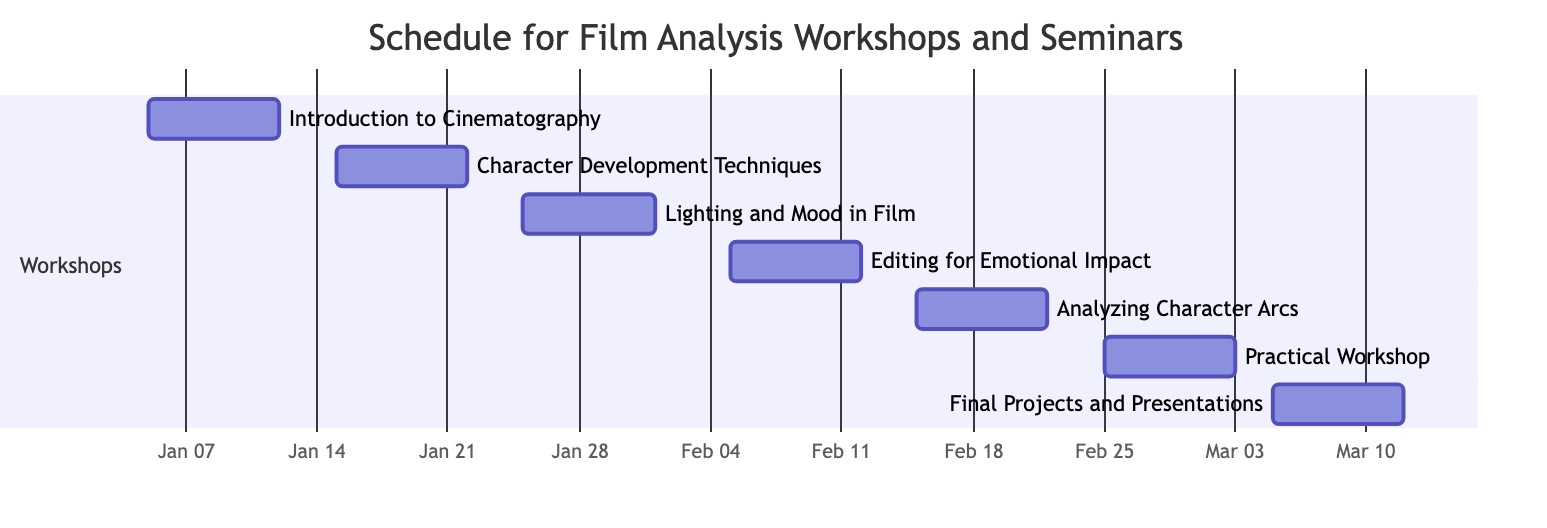What is the duration of the "Editing for Emotional Impact" workshop? The duration of a workshop in a Gantt chart can be found next to its title. For "Editing for Emotional Impact", the duration is indicated as 7 days.
Answer: 7 days Which workshop occurs right after "Lighting and Mood in Film"? To determine which workshop occurs next, we can look at the end date of "Lighting and Mood in Film", which is February 1, 2024. The next workshop starts on February 5, 2024, which is "Editing for Emotional Impact".
Answer: Editing for Emotional Impact How many workshops are scheduled between January 15, 2024, and February 15, 2024? We check the workshops starting between the given dates. "Character Development Techniques" starts on January 15 and "Lighting and Mood in Film" begins on January 25, followed by "Editing for Emotional Impact" starting on February 5 and "Analyzing Character Arcs" on February 15. There are four workshops in this timeframe.
Answer: 4 What is the title of the last workshop scheduled in the diagram? The last workshop can be identified by looking at the section where the workshops are listed and identifying the one that is positioned furthest on the timeline. The final workshop is "Final Projects and Presentations".
Answer: Final Projects and Presentations Is there any overlap between "Practical Workshop: Shooting Scenes" and "Final Projects and Presentations"? We check the start and end dates of both workshops. "Practical Workshop: Shooting Scenes" runs from February 25 to March 3, 2024, and "Final Projects and Presentations" starts on March 5, 2024. Since there is no overlap in the date ranges, the answer is no.
Answer: No What is the total number of workshops listed in the diagram? To find the total number of workshops, we can count the entries in the workshops section of the diagram. There are seven entries for workshops.
Answer: 7 When does the "Analyzing Character Arcs" workshop start? The specific start date for "Analyzing Character Arcs" is listed directly beside its title. It begins on February 15, 2024.
Answer: February 15, 2024 